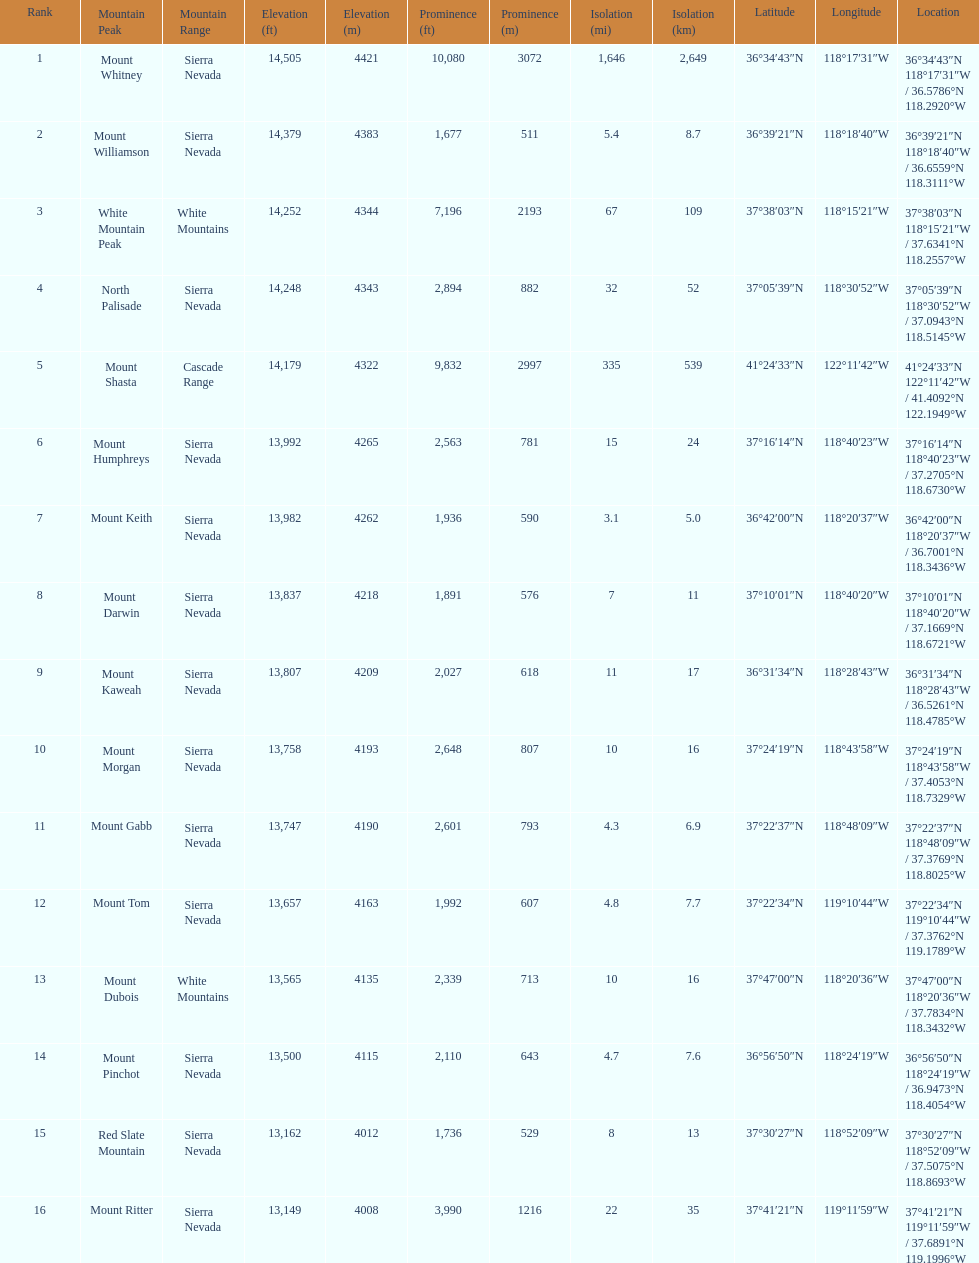What is the next highest mountain peak after north palisade? Mount Shasta. 